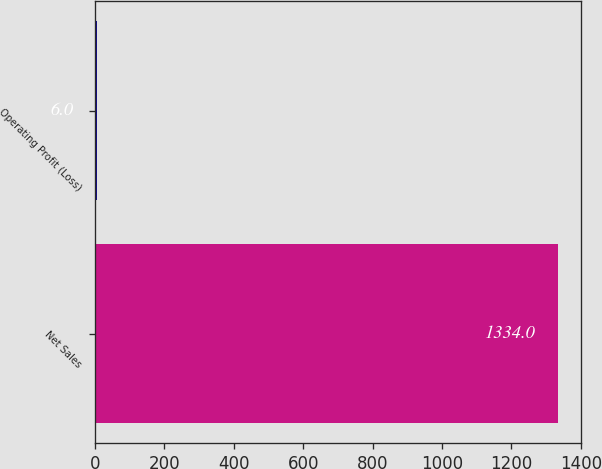Convert chart to OTSL. <chart><loc_0><loc_0><loc_500><loc_500><bar_chart><fcel>Net Sales<fcel>Operating Profit (Loss)<nl><fcel>1334<fcel>6<nl></chart> 